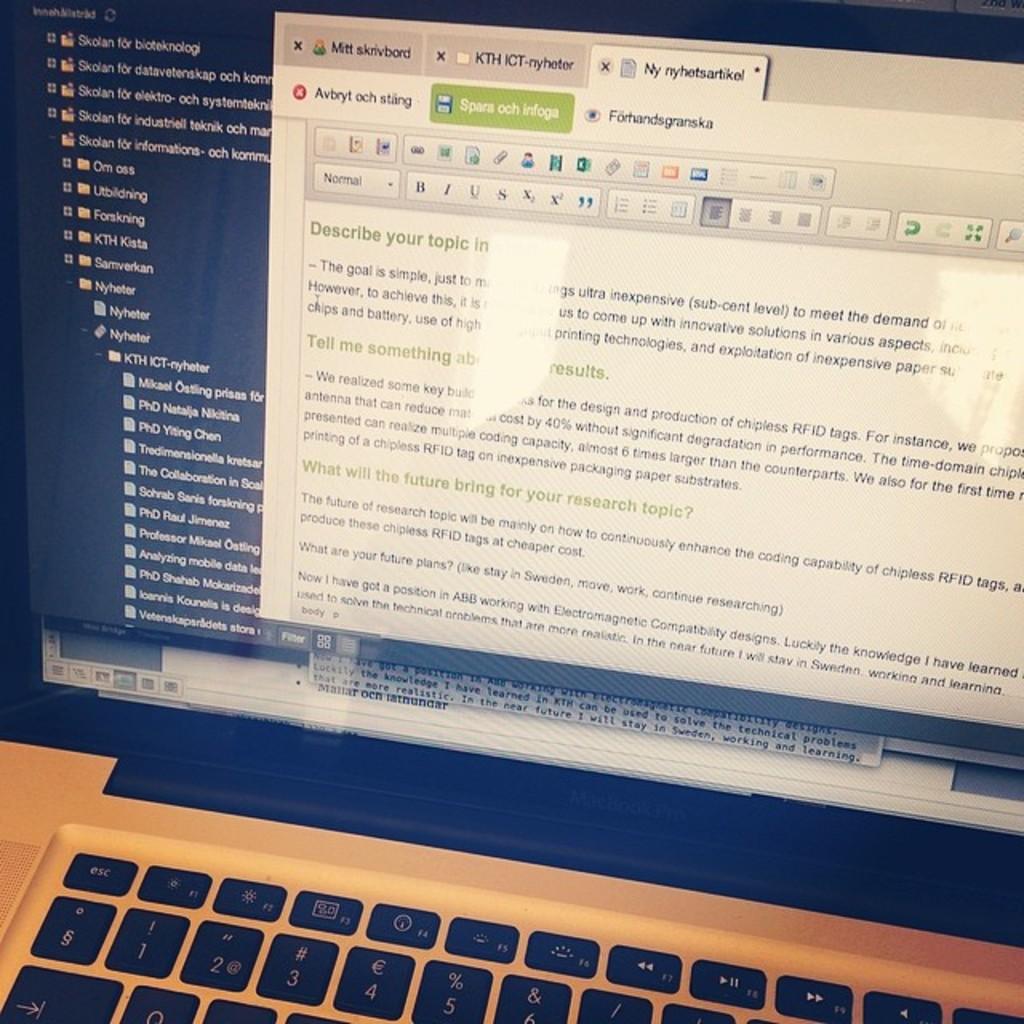What does the text say about the topic?
Offer a very short reply. Describe your topic. What does the green tab say?
Your response must be concise. Spars och infoga. 